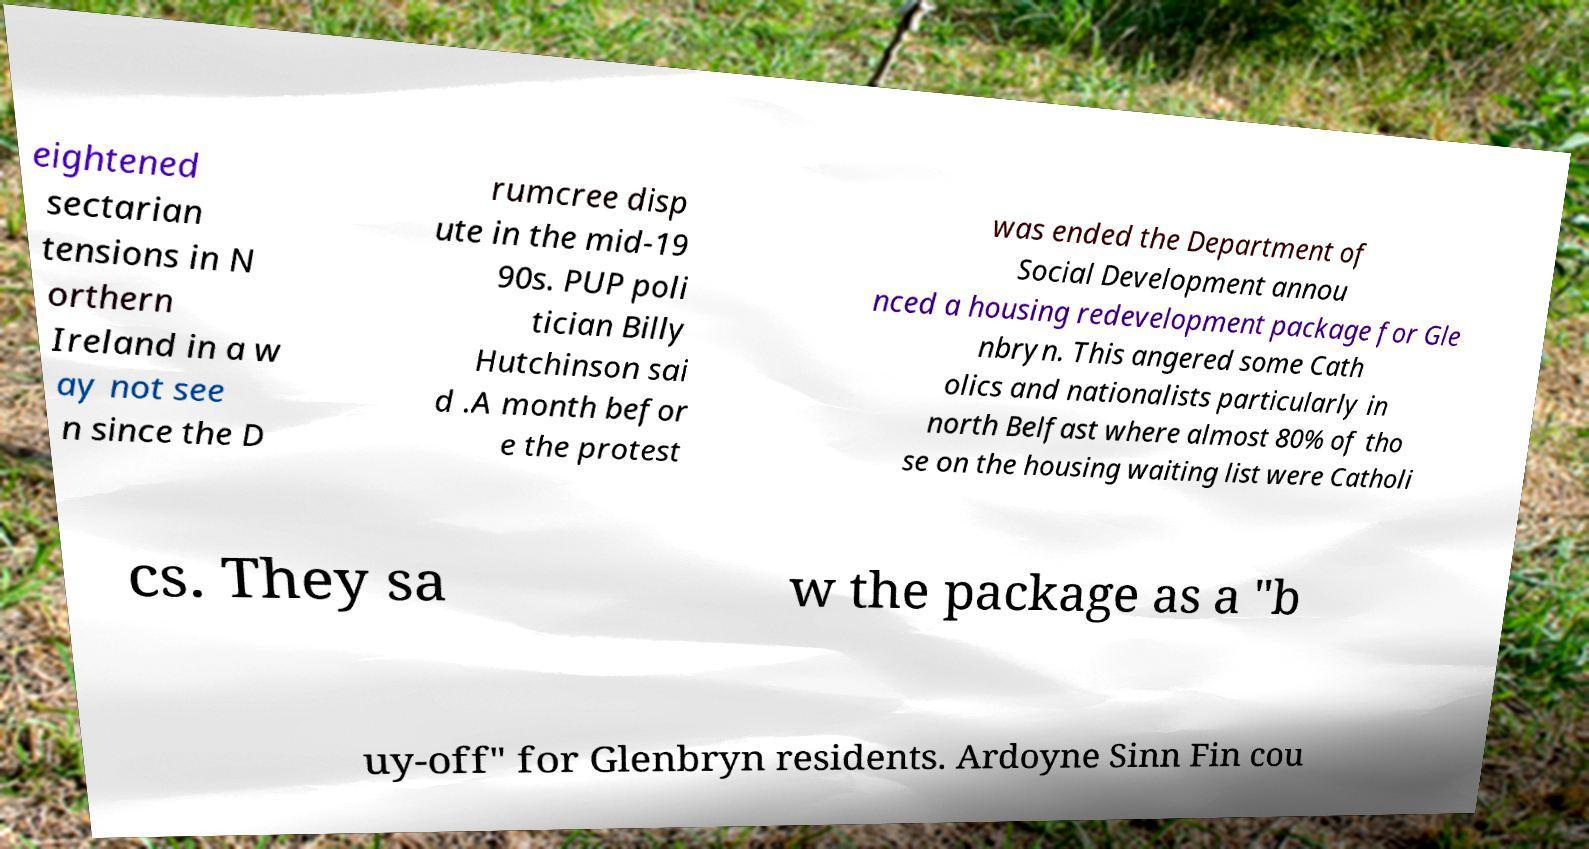Please identify and transcribe the text found in this image. eightened sectarian tensions in N orthern Ireland in a w ay not see n since the D rumcree disp ute in the mid-19 90s. PUP poli tician Billy Hutchinson sai d .A month befor e the protest was ended the Department of Social Development annou nced a housing redevelopment package for Gle nbryn. This angered some Cath olics and nationalists particularly in north Belfast where almost 80% of tho se on the housing waiting list were Catholi cs. They sa w the package as a "b uy-off" for Glenbryn residents. Ardoyne Sinn Fin cou 